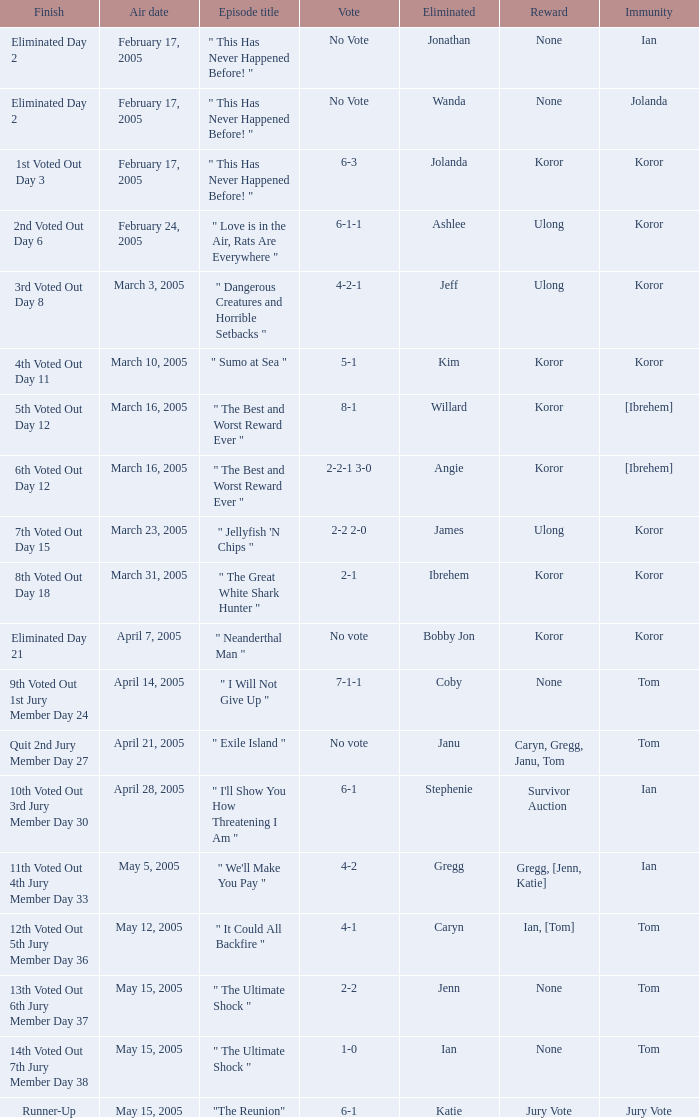What was the vote tally on the episode aired May 5, 2005? 4-2. 